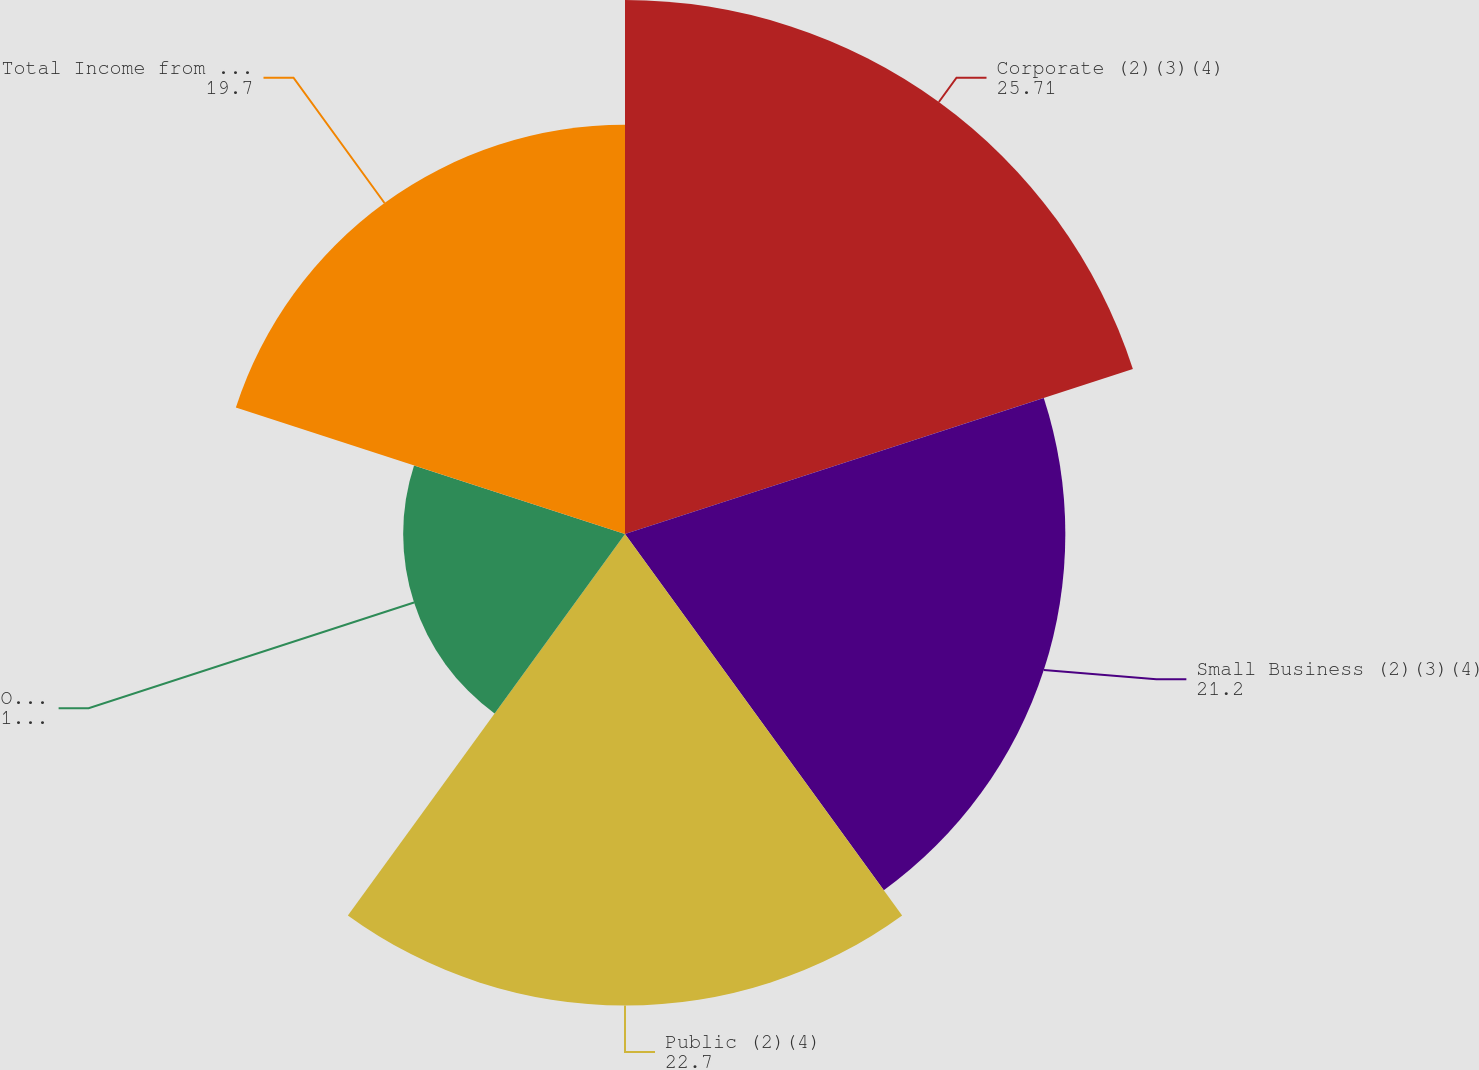Convert chart to OTSL. <chart><loc_0><loc_0><loc_500><loc_500><pie_chart><fcel>Corporate (2)(3)(4)<fcel>Small Business (2)(3)(4)<fcel>Public (2)(4)<fcel>Other (4)(5)<fcel>Total Income from operations<nl><fcel>25.71%<fcel>21.2%<fcel>22.7%<fcel>10.68%<fcel>19.7%<nl></chart> 